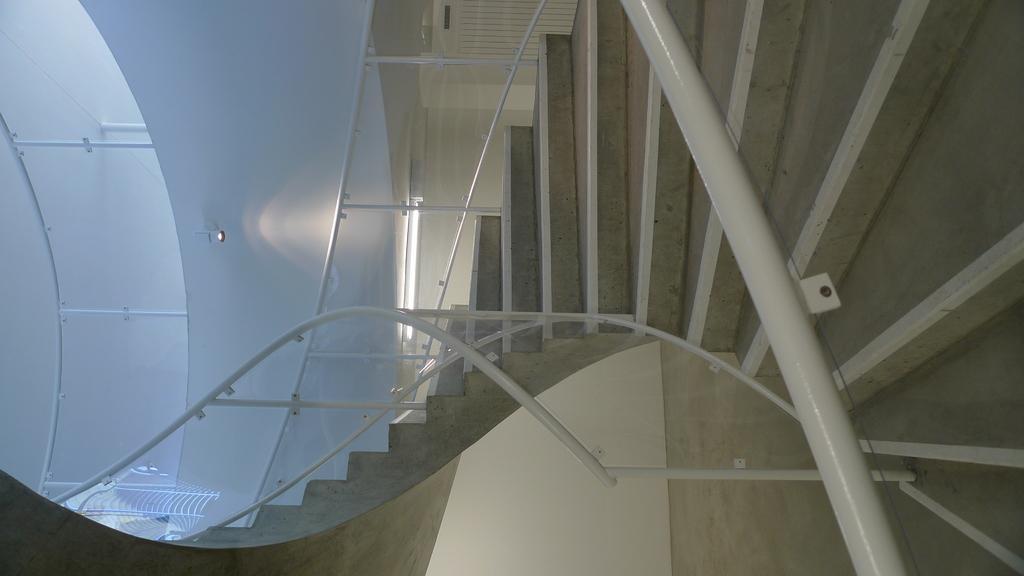Can you describe this image briefly? In this image we can see steps, rods, walls, glass and light. 